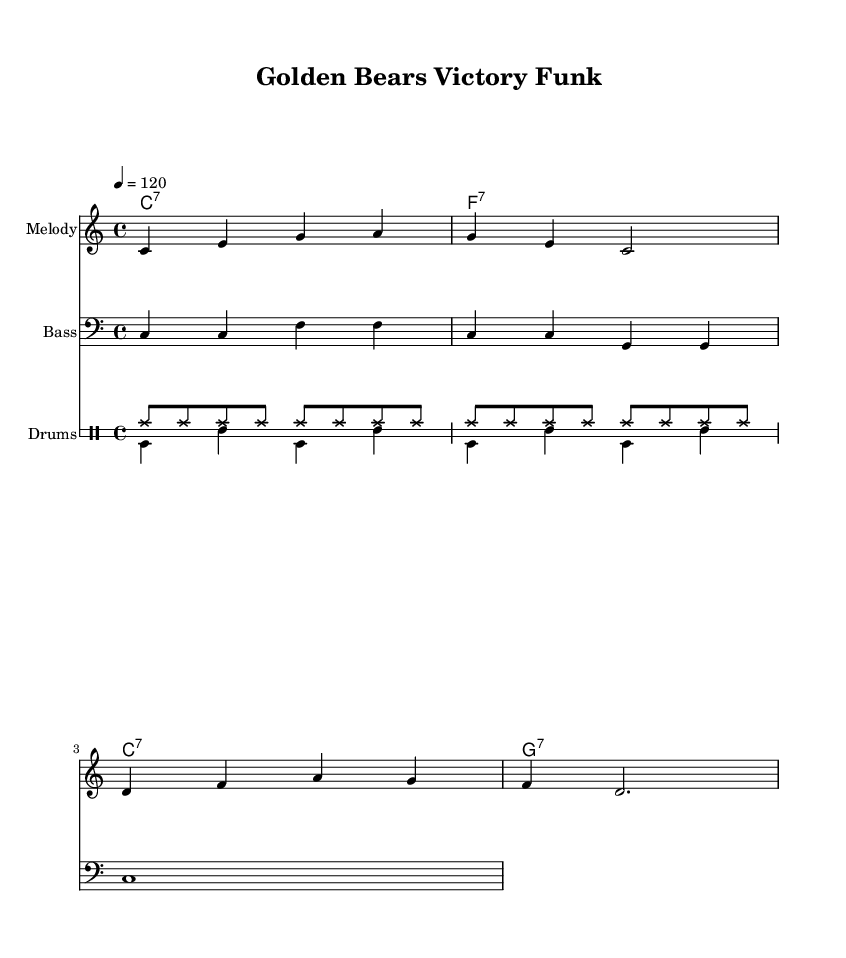What is the key signature of this music? The key signature is indicated at the beginning of the piece, showing that it is in C major, which has no sharps or flats.
Answer: C major What is the time signature of the composition? The time signature is located at the beginning of the score, displaying a 4/4 time signature which indicates four beats per measure.
Answer: 4/4 What is the tempo marking indicated in the score? The tempo is specified as a quarter note equals 120 beats per minute, which is noted above the staff.
Answer: 120 How many measures are there in the melody section? Counting the measures in the melody notation, there are four measures in total, as indicated by the bar lines present in the music.
Answer: 4 What type of chords are used in the harmonies? The chord mode indicates major seventh chords, as shown by the "7" notation attached to the chord root letters C, F, and G.
Answer: Major seventh chords Which instruments are included in this arrangement? The score includes sections for melody, bass, and drums, specified by different staff names within the score layout.
Answer: Melody, Bass, Drums What is the theme of the lyrics provided in the piece? The lyrics celebrate college football victories by expressing enthusiasm for the Golden Bears, embodying the spirit of success and celebration in sports.
Answer: Celebration 